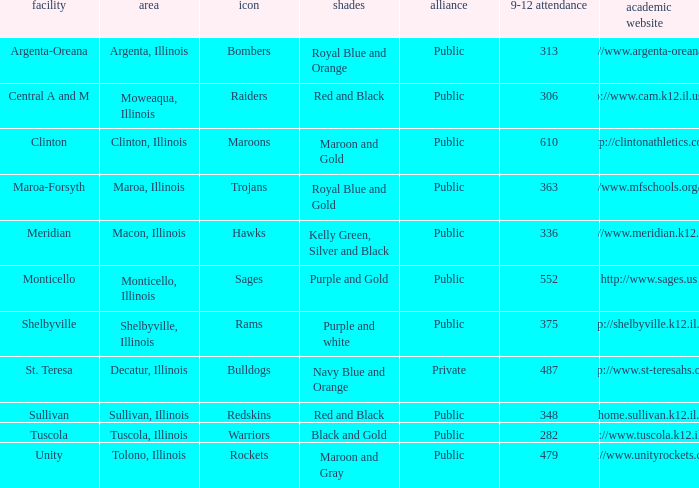What location has 363 students enrolled in the 9th to 12th grades? Maroa, Illinois. 